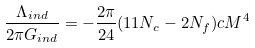Convert formula to latex. <formula><loc_0><loc_0><loc_500><loc_500>\frac { \Lambda _ { i n d } } { 2 \pi G _ { i n d } } = - \frac { 2 \pi } { 2 4 } ( 1 1 N _ { c } - 2 N _ { f } ) c M ^ { 4 }</formula> 